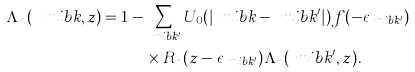<formula> <loc_0><loc_0><loc_500><loc_500>\Lambda _ { n } ( \ m i b { k } , z ) = 1 & - \sum _ { \ m i b { k } ^ { \prime } } U _ { 0 } ( | \ m i b { k } - \ m i b { k } ^ { \prime } | ) f ( - \epsilon _ { \ m i b { k } ^ { \prime } } ) \\ & \quad \times R _ { n } ( z - \epsilon _ { \ m i b { k } ^ { \prime } } ) \Lambda _ { n } ( \ m i b { k } ^ { \prime } , z ) .</formula> 